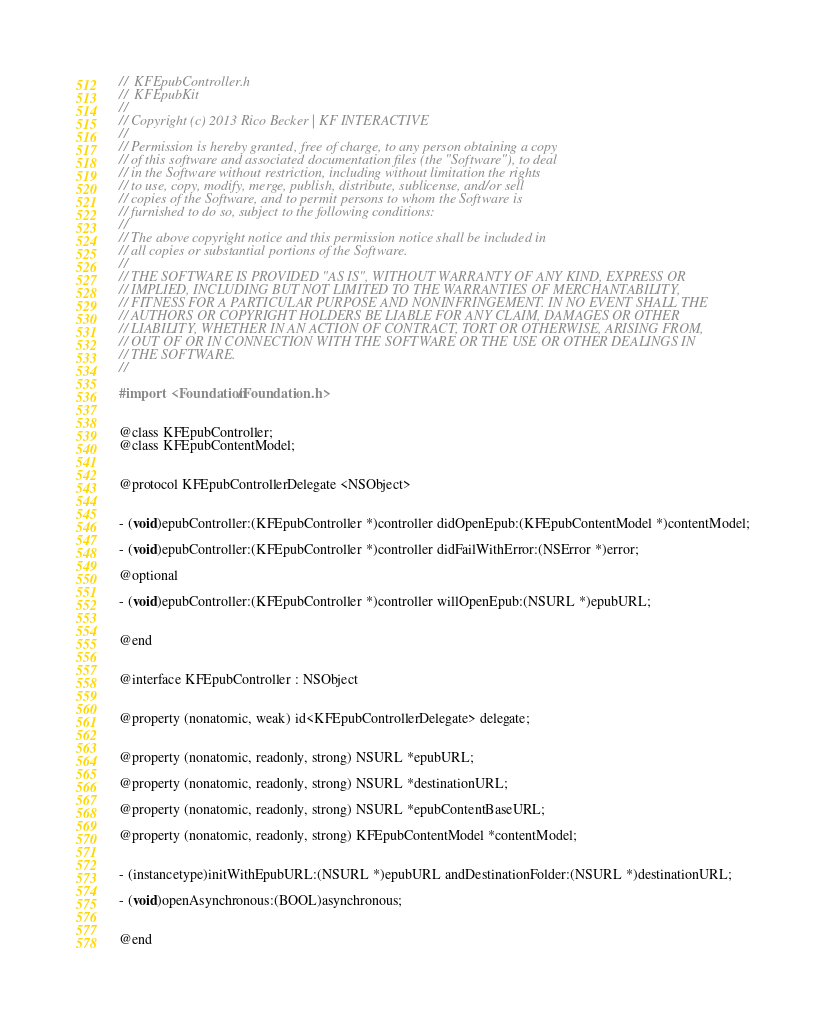<code> <loc_0><loc_0><loc_500><loc_500><_C_>//  KFEpubController.h
//  KFEpubKit
//
// Copyright (c) 2013 Rico Becker | KF INTERACTIVE
//
// Permission is hereby granted, free of charge, to any person obtaining a copy
// of this software and associated documentation files (the "Software"), to deal
// in the Software without restriction, including without limitation the rights
// to use, copy, modify, merge, publish, distribute, sublicense, and/or sell
// copies of the Software, and to permit persons to whom the Software is
// furnished to do so, subject to the following conditions:
//
// The above copyright notice and this permission notice shall be included in
// all copies or substantial portions of the Software.
//
// THE SOFTWARE IS PROVIDED "AS IS", WITHOUT WARRANTY OF ANY KIND, EXPRESS OR
// IMPLIED, INCLUDING BUT NOT LIMITED TO THE WARRANTIES OF MERCHANTABILITY,
// FITNESS FOR A PARTICULAR PURPOSE AND NONINFRINGEMENT. IN NO EVENT SHALL THE
// AUTHORS OR COPYRIGHT HOLDERS BE LIABLE FOR ANY CLAIM, DAMAGES OR OTHER
// LIABILITY, WHETHER IN AN ACTION OF CONTRACT, TORT OR OTHERWISE, ARISING FROM,
// OUT OF OR IN CONNECTION WITH THE SOFTWARE OR THE USE OR OTHER DEALINGS IN
// THE SOFTWARE.
//

#import <Foundation/Foundation.h>


@class KFEpubController;
@class KFEpubContentModel;


@protocol KFEpubControllerDelegate <NSObject>


- (void)epubController:(KFEpubController *)controller didOpenEpub:(KFEpubContentModel *)contentModel;

- (void)epubController:(KFEpubController *)controller didFailWithError:(NSError *)error;

@optional

- (void)epubController:(KFEpubController *)controller willOpenEpub:(NSURL *)epubURL;


@end


@interface KFEpubController : NSObject


@property (nonatomic, weak) id<KFEpubControllerDelegate> delegate;


@property (nonatomic, readonly, strong) NSURL *epubURL;

@property (nonatomic, readonly, strong) NSURL *destinationURL;

@property (nonatomic, readonly, strong) NSURL *epubContentBaseURL;

@property (nonatomic, readonly, strong) KFEpubContentModel *contentModel;


- (instancetype)initWithEpubURL:(NSURL *)epubURL andDestinationFolder:(NSURL *)destinationURL;

- (void)openAsynchronous:(BOOL)asynchronous;


@end
</code> 